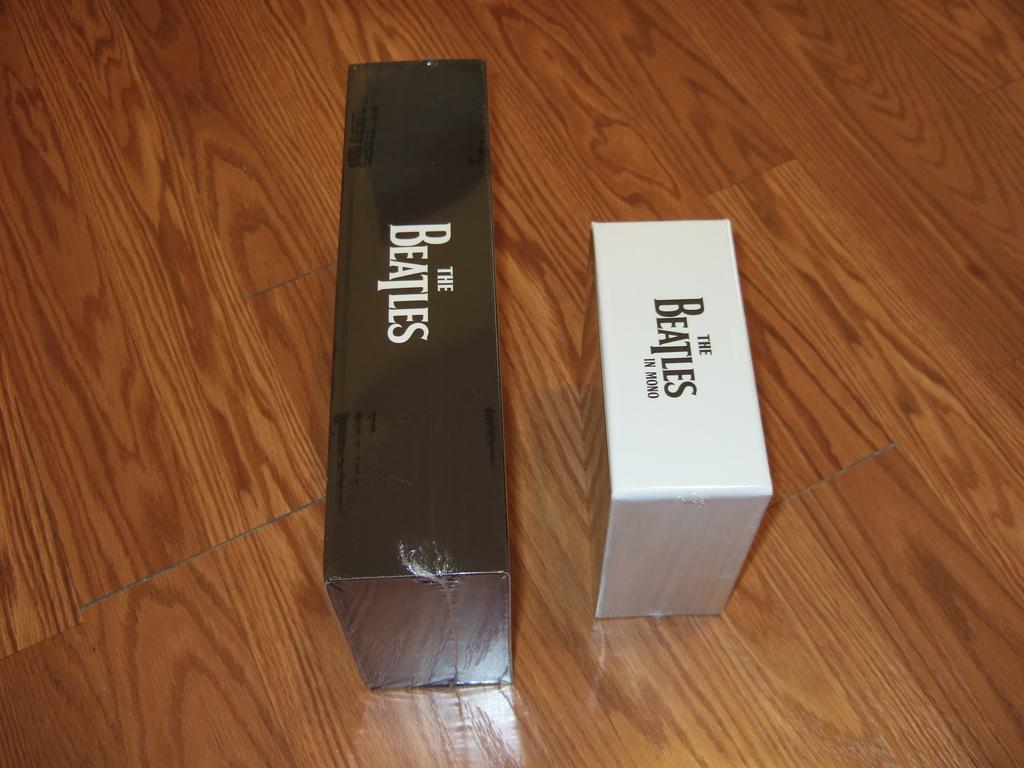<image>
Share a concise interpretation of the image provided. The Beatles and The Beatles in mono are printed on the sides of these boxes. 